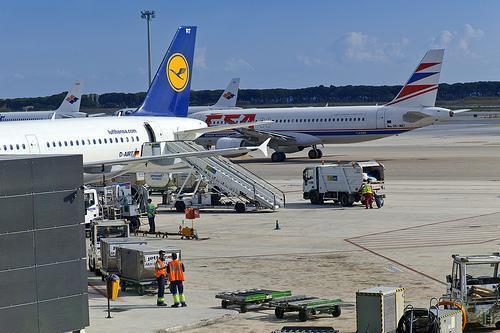How many airplanes are there?
Give a very brief answer. 4. How many airplanes are the same?
Give a very brief answer. 2. 